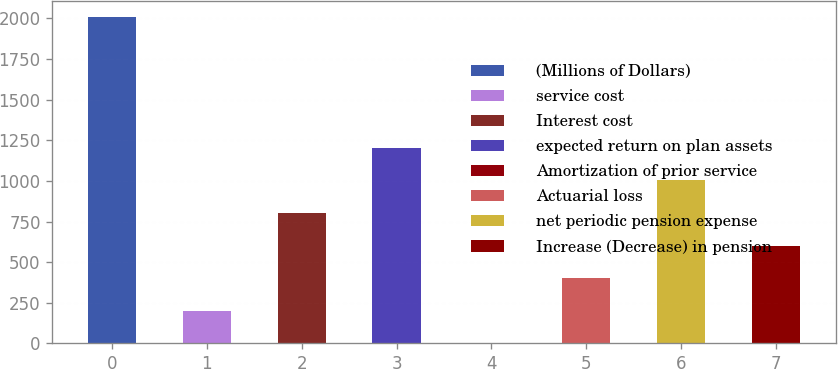Convert chart to OTSL. <chart><loc_0><loc_0><loc_500><loc_500><bar_chart><fcel>(Millions of Dollars)<fcel>service cost<fcel>Interest cost<fcel>expected return on plan assets<fcel>Amortization of prior service<fcel>Actuarial loss<fcel>net periodic pension expense<fcel>Increase (Decrease) in pension<nl><fcel>2006<fcel>200.78<fcel>802.52<fcel>1203.68<fcel>0.2<fcel>401.36<fcel>1003.1<fcel>601.94<nl></chart> 